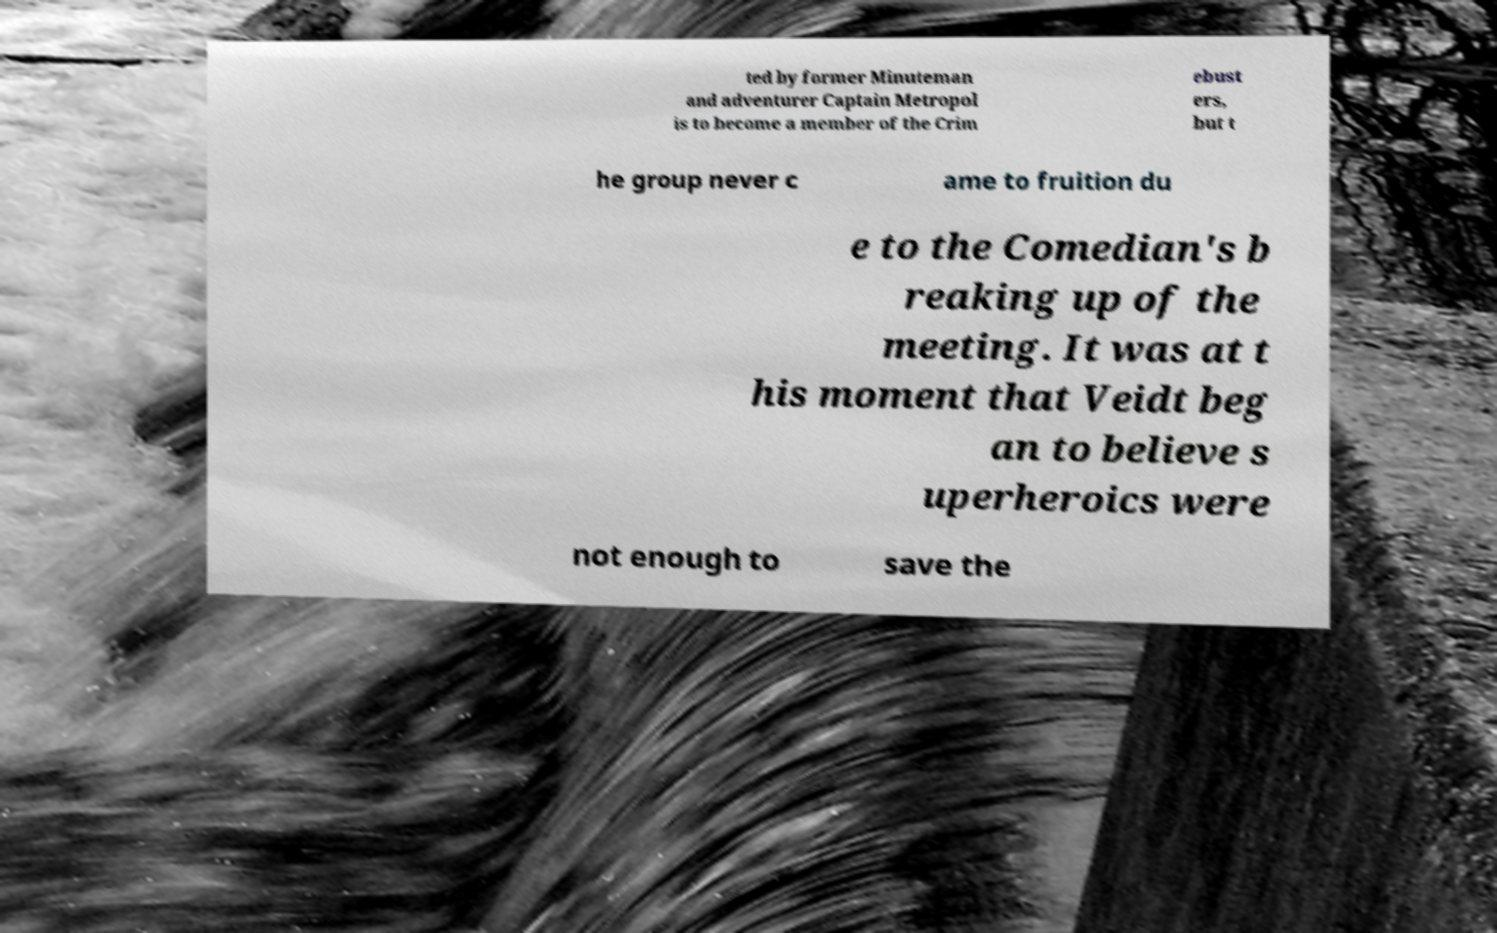What messages or text are displayed in this image? I need them in a readable, typed format. ted by former Minuteman and adventurer Captain Metropol is to become a member of the Crim ebust ers, but t he group never c ame to fruition du e to the Comedian's b reaking up of the meeting. It was at t his moment that Veidt beg an to believe s uperheroics were not enough to save the 